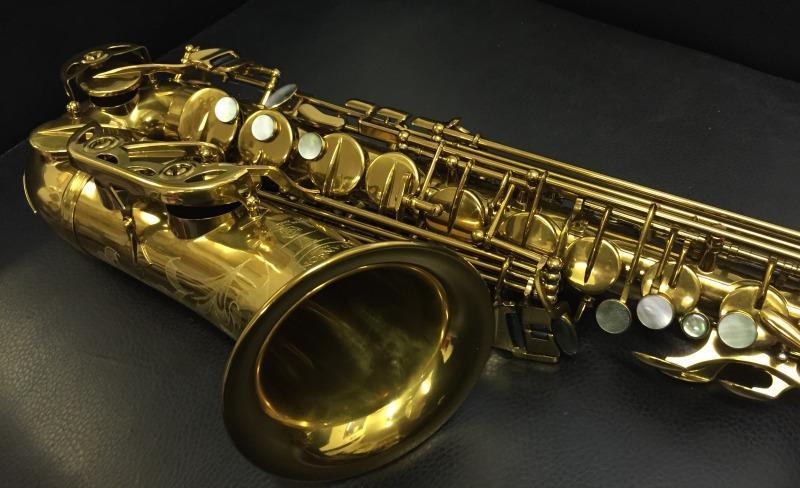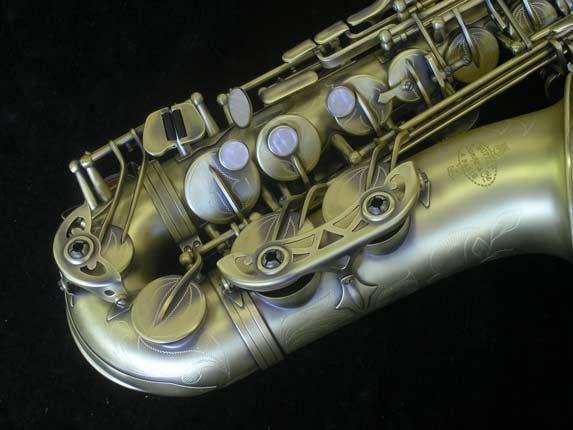The first image is the image on the left, the second image is the image on the right. Given the left and right images, does the statement "One sax is laying exactly horizontally." hold true? Answer yes or no. No. The first image is the image on the left, the second image is the image on the right. For the images shown, is this caption "The combined images include an open case, a saxophone displayed horizontally, and a saxophone displayed diagonally." true? Answer yes or no. No. 